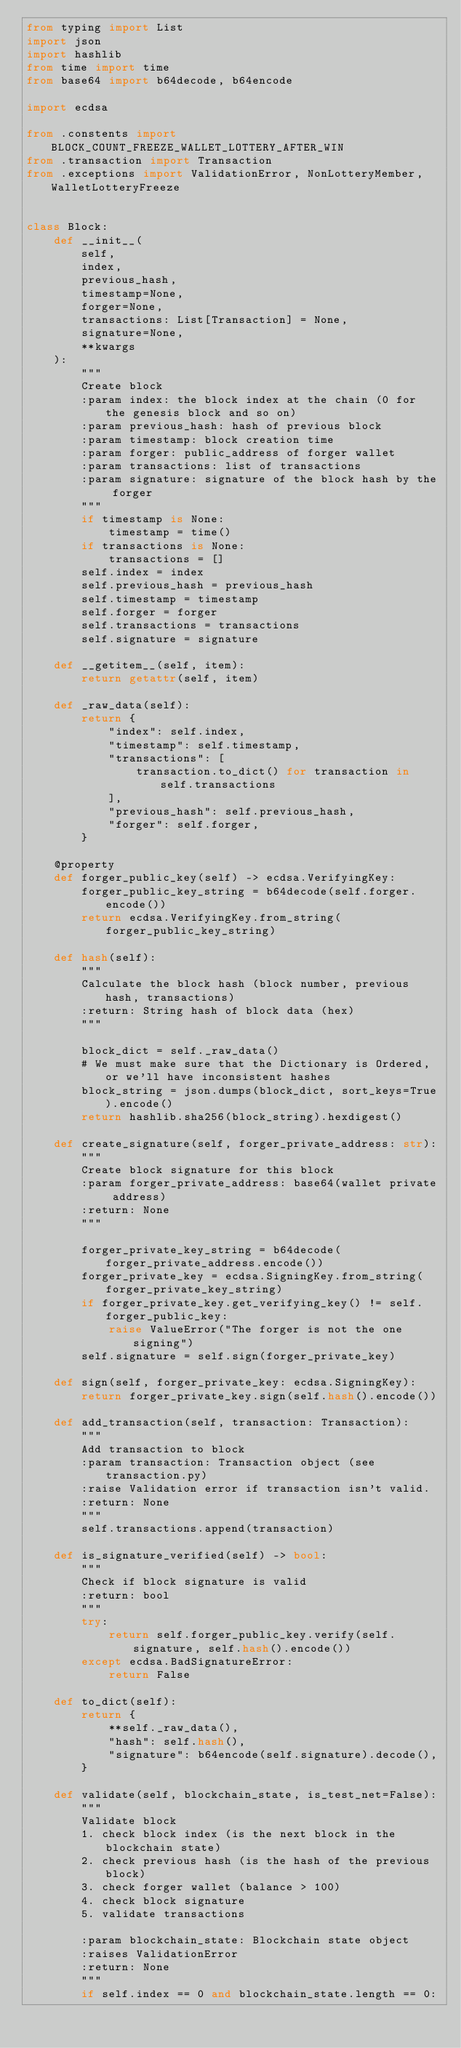<code> <loc_0><loc_0><loc_500><loc_500><_Python_>from typing import List
import json
import hashlib
from time import time
from base64 import b64decode, b64encode

import ecdsa

from .constents import BLOCK_COUNT_FREEZE_WALLET_LOTTERY_AFTER_WIN
from .transaction import Transaction
from .exceptions import ValidationError, NonLotteryMember, WalletLotteryFreeze


class Block:
    def __init__(
        self,
        index,
        previous_hash,
        timestamp=None,
        forger=None,
        transactions: List[Transaction] = None,
        signature=None,
        **kwargs
    ):
        """
        Create block
        :param index: the block index at the chain (0 for the genesis block and so on)
        :param previous_hash: hash of previous block
        :param timestamp: block creation time
        :param forger: public_address of forger wallet
        :param transactions: list of transactions
        :param signature: signature of the block hash by the forger
        """
        if timestamp is None:
            timestamp = time()
        if transactions is None:
            transactions = []
        self.index = index
        self.previous_hash = previous_hash
        self.timestamp = timestamp
        self.forger = forger
        self.transactions = transactions
        self.signature = signature

    def __getitem__(self, item):
        return getattr(self, item)

    def _raw_data(self):
        return {
            "index": self.index,
            "timestamp": self.timestamp,
            "transactions": [
                transaction.to_dict() for transaction in self.transactions
            ],
            "previous_hash": self.previous_hash,
            "forger": self.forger,
        }

    @property
    def forger_public_key(self) -> ecdsa.VerifyingKey:
        forger_public_key_string = b64decode(self.forger.encode())
        return ecdsa.VerifyingKey.from_string(forger_public_key_string)

    def hash(self):
        """
        Calculate the block hash (block number, previous hash, transactions)
        :return: String hash of block data (hex)
        """

        block_dict = self._raw_data()
        # We must make sure that the Dictionary is Ordered, or we'll have inconsistent hashes
        block_string = json.dumps(block_dict, sort_keys=True).encode()
        return hashlib.sha256(block_string).hexdigest()

    def create_signature(self, forger_private_address: str):
        """
        Create block signature for this block
        :param forger_private_address: base64(wallet private address)
        :return: None
        """

        forger_private_key_string = b64decode(forger_private_address.encode())
        forger_private_key = ecdsa.SigningKey.from_string(forger_private_key_string)
        if forger_private_key.get_verifying_key() != self.forger_public_key:
            raise ValueError("The forger is not the one signing")
        self.signature = self.sign(forger_private_key)

    def sign(self, forger_private_key: ecdsa.SigningKey):
        return forger_private_key.sign(self.hash().encode())

    def add_transaction(self, transaction: Transaction):
        """
        Add transaction to block
        :param transaction: Transaction object (see transaction.py)
        :raise Validation error if transaction isn't valid.
        :return: None
        """
        self.transactions.append(transaction)

    def is_signature_verified(self) -> bool:
        """
        Check if block signature is valid
        :return: bool
        """
        try:
            return self.forger_public_key.verify(self.signature, self.hash().encode())
        except ecdsa.BadSignatureError:
            return False

    def to_dict(self):
        return {
            **self._raw_data(),
            "hash": self.hash(),
            "signature": b64encode(self.signature).decode(),
        }

    def validate(self, blockchain_state, is_test_net=False):
        """
        Validate block
        1. check block index (is the next block in the blockchain state)
        2. check previous hash (is the hash of the previous block)
        3. check forger wallet (balance > 100)
        4. check block signature
        5. validate transactions

        :param blockchain_state: Blockchain state object
        :raises ValidationError
        :return: None
        """
        if self.index == 0 and blockchain_state.length == 0:</code> 